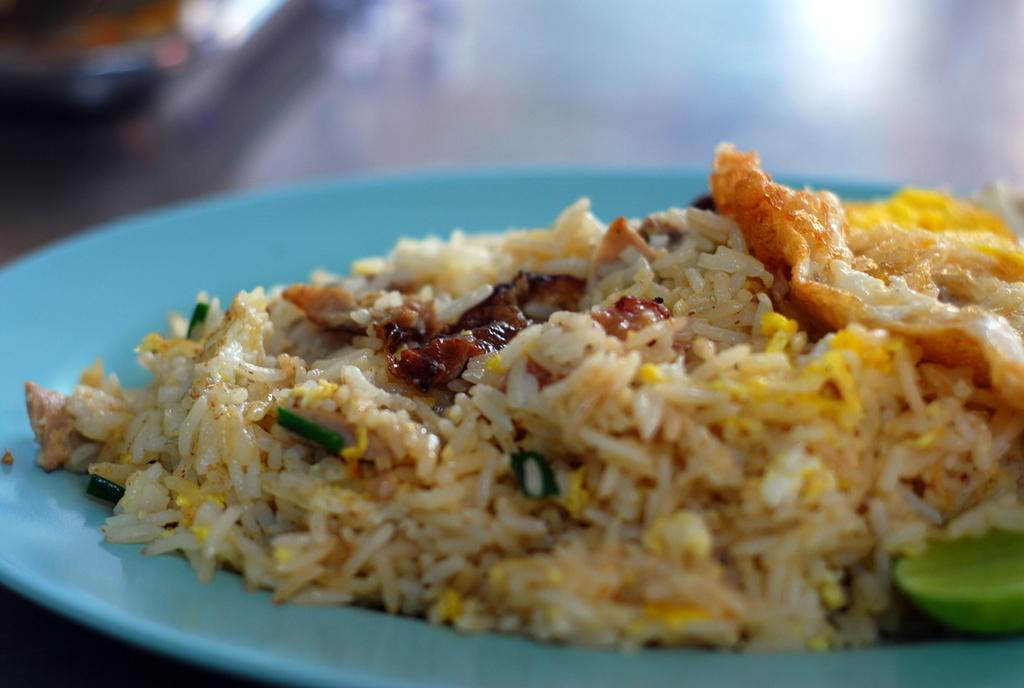Could you give a brief overview of what you see in this image? In this picture we can see some food item placed in the plate. 